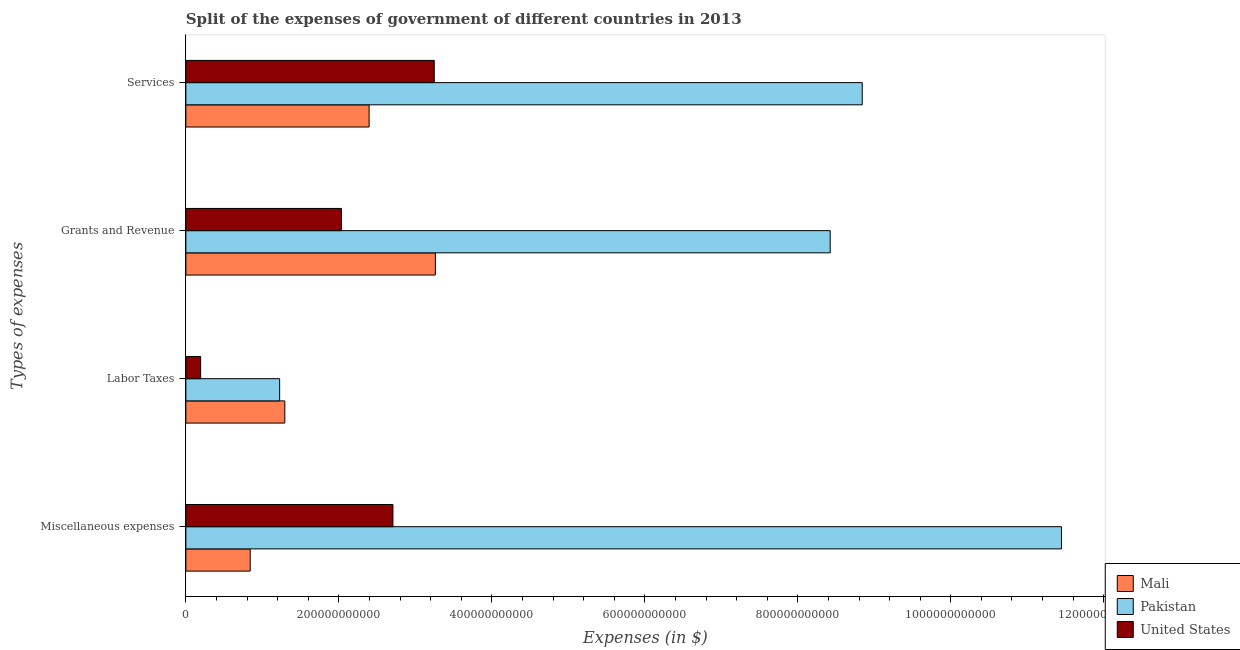How many different coloured bars are there?
Ensure brevity in your answer.  3. How many groups of bars are there?
Provide a succinct answer. 4. Are the number of bars per tick equal to the number of legend labels?
Your response must be concise. Yes. Are the number of bars on each tick of the Y-axis equal?
Give a very brief answer. Yes. How many bars are there on the 4th tick from the top?
Offer a terse response. 3. How many bars are there on the 3rd tick from the bottom?
Give a very brief answer. 3. What is the label of the 4th group of bars from the top?
Provide a succinct answer. Miscellaneous expenses. What is the amount spent on services in United States?
Keep it short and to the point. 3.25e+11. Across all countries, what is the maximum amount spent on grants and revenue?
Your answer should be compact. 8.42e+11. Across all countries, what is the minimum amount spent on labor taxes?
Ensure brevity in your answer.  1.93e+1. In which country was the amount spent on services minimum?
Your response must be concise. Mali. What is the total amount spent on labor taxes in the graph?
Keep it short and to the point. 2.71e+11. What is the difference between the amount spent on grants and revenue in United States and that in Mali?
Offer a terse response. -1.23e+11. What is the difference between the amount spent on labor taxes in Mali and the amount spent on miscellaneous expenses in United States?
Your response must be concise. -1.41e+11. What is the average amount spent on services per country?
Keep it short and to the point. 4.83e+11. What is the difference between the amount spent on miscellaneous expenses and amount spent on services in Pakistan?
Your response must be concise. 2.60e+11. In how many countries, is the amount spent on miscellaneous expenses greater than 160000000000 $?
Provide a short and direct response. 2. What is the ratio of the amount spent on services in United States to that in Mali?
Ensure brevity in your answer.  1.36. Is the amount spent on miscellaneous expenses in Pakistan less than that in United States?
Offer a very short reply. No. What is the difference between the highest and the second highest amount spent on services?
Offer a very short reply. 5.60e+11. What is the difference between the highest and the lowest amount spent on services?
Keep it short and to the point. 6.45e+11. Is it the case that in every country, the sum of the amount spent on labor taxes and amount spent on services is greater than the sum of amount spent on miscellaneous expenses and amount spent on grants and revenue?
Offer a terse response. No. What does the 3rd bar from the top in Miscellaneous expenses represents?
Keep it short and to the point. Mali. What does the 1st bar from the bottom in Labor Taxes represents?
Your answer should be compact. Mali. Is it the case that in every country, the sum of the amount spent on miscellaneous expenses and amount spent on labor taxes is greater than the amount spent on grants and revenue?
Your response must be concise. No. How many bars are there?
Your response must be concise. 12. How many countries are there in the graph?
Your answer should be compact. 3. What is the difference between two consecutive major ticks on the X-axis?
Your answer should be very brief. 2.00e+11. Does the graph contain any zero values?
Keep it short and to the point. No. Does the graph contain grids?
Give a very brief answer. No. How many legend labels are there?
Keep it short and to the point. 3. How are the legend labels stacked?
Offer a very short reply. Vertical. What is the title of the graph?
Keep it short and to the point. Split of the expenses of government of different countries in 2013. What is the label or title of the X-axis?
Give a very brief answer. Expenses (in $). What is the label or title of the Y-axis?
Your response must be concise. Types of expenses. What is the Expenses (in $) of Mali in Miscellaneous expenses?
Provide a short and direct response. 8.41e+1. What is the Expenses (in $) in Pakistan in Miscellaneous expenses?
Your response must be concise. 1.14e+12. What is the Expenses (in $) of United States in Miscellaneous expenses?
Provide a succinct answer. 2.71e+11. What is the Expenses (in $) of Mali in Labor Taxes?
Make the answer very short. 1.29e+11. What is the Expenses (in $) in Pakistan in Labor Taxes?
Offer a terse response. 1.23e+11. What is the Expenses (in $) in United States in Labor Taxes?
Provide a succinct answer. 1.93e+1. What is the Expenses (in $) in Mali in Grants and Revenue?
Offer a very short reply. 3.26e+11. What is the Expenses (in $) of Pakistan in Grants and Revenue?
Your answer should be compact. 8.42e+11. What is the Expenses (in $) in United States in Grants and Revenue?
Your response must be concise. 2.03e+11. What is the Expenses (in $) in Mali in Services?
Your answer should be very brief. 2.40e+11. What is the Expenses (in $) of Pakistan in Services?
Make the answer very short. 8.84e+11. What is the Expenses (in $) of United States in Services?
Keep it short and to the point. 3.25e+11. Across all Types of expenses, what is the maximum Expenses (in $) of Mali?
Give a very brief answer. 3.26e+11. Across all Types of expenses, what is the maximum Expenses (in $) of Pakistan?
Your answer should be very brief. 1.14e+12. Across all Types of expenses, what is the maximum Expenses (in $) in United States?
Your answer should be compact. 3.25e+11. Across all Types of expenses, what is the minimum Expenses (in $) of Mali?
Ensure brevity in your answer.  8.41e+1. Across all Types of expenses, what is the minimum Expenses (in $) of Pakistan?
Make the answer very short. 1.23e+11. Across all Types of expenses, what is the minimum Expenses (in $) of United States?
Provide a short and direct response. 1.93e+1. What is the total Expenses (in $) of Mali in the graph?
Give a very brief answer. 7.79e+11. What is the total Expenses (in $) in Pakistan in the graph?
Keep it short and to the point. 2.99e+12. What is the total Expenses (in $) in United States in the graph?
Offer a terse response. 8.18e+11. What is the difference between the Expenses (in $) in Mali in Miscellaneous expenses and that in Labor Taxes?
Make the answer very short. -4.52e+1. What is the difference between the Expenses (in $) in Pakistan in Miscellaneous expenses and that in Labor Taxes?
Offer a terse response. 1.02e+12. What is the difference between the Expenses (in $) in United States in Miscellaneous expenses and that in Labor Taxes?
Provide a short and direct response. 2.51e+11. What is the difference between the Expenses (in $) of Mali in Miscellaneous expenses and that in Grants and Revenue?
Make the answer very short. -2.42e+11. What is the difference between the Expenses (in $) in Pakistan in Miscellaneous expenses and that in Grants and Revenue?
Provide a succinct answer. 3.02e+11. What is the difference between the Expenses (in $) of United States in Miscellaneous expenses and that in Grants and Revenue?
Keep it short and to the point. 6.73e+1. What is the difference between the Expenses (in $) in Mali in Miscellaneous expenses and that in Services?
Your response must be concise. -1.55e+11. What is the difference between the Expenses (in $) of Pakistan in Miscellaneous expenses and that in Services?
Provide a succinct answer. 2.60e+11. What is the difference between the Expenses (in $) of United States in Miscellaneous expenses and that in Services?
Ensure brevity in your answer.  -5.40e+1. What is the difference between the Expenses (in $) in Mali in Labor Taxes and that in Grants and Revenue?
Your answer should be very brief. -1.97e+11. What is the difference between the Expenses (in $) in Pakistan in Labor Taxes and that in Grants and Revenue?
Offer a very short reply. -7.20e+11. What is the difference between the Expenses (in $) of United States in Labor Taxes and that in Grants and Revenue?
Offer a terse response. -1.84e+11. What is the difference between the Expenses (in $) of Mali in Labor Taxes and that in Services?
Your response must be concise. -1.10e+11. What is the difference between the Expenses (in $) in Pakistan in Labor Taxes and that in Services?
Make the answer very short. -7.62e+11. What is the difference between the Expenses (in $) in United States in Labor Taxes and that in Services?
Provide a succinct answer. -3.05e+11. What is the difference between the Expenses (in $) of Mali in Grants and Revenue and that in Services?
Your answer should be compact. 8.66e+1. What is the difference between the Expenses (in $) in Pakistan in Grants and Revenue and that in Services?
Make the answer very short. -4.19e+1. What is the difference between the Expenses (in $) of United States in Grants and Revenue and that in Services?
Keep it short and to the point. -1.21e+11. What is the difference between the Expenses (in $) in Mali in Miscellaneous expenses and the Expenses (in $) in Pakistan in Labor Taxes?
Give a very brief answer. -3.84e+1. What is the difference between the Expenses (in $) in Mali in Miscellaneous expenses and the Expenses (in $) in United States in Labor Taxes?
Offer a very short reply. 6.48e+1. What is the difference between the Expenses (in $) in Pakistan in Miscellaneous expenses and the Expenses (in $) in United States in Labor Taxes?
Ensure brevity in your answer.  1.13e+12. What is the difference between the Expenses (in $) of Mali in Miscellaneous expenses and the Expenses (in $) of Pakistan in Grants and Revenue?
Your answer should be very brief. -7.58e+11. What is the difference between the Expenses (in $) of Mali in Miscellaneous expenses and the Expenses (in $) of United States in Grants and Revenue?
Make the answer very short. -1.19e+11. What is the difference between the Expenses (in $) of Pakistan in Miscellaneous expenses and the Expenses (in $) of United States in Grants and Revenue?
Provide a succinct answer. 9.41e+11. What is the difference between the Expenses (in $) in Mali in Miscellaneous expenses and the Expenses (in $) in Pakistan in Services?
Give a very brief answer. -8.00e+11. What is the difference between the Expenses (in $) of Mali in Miscellaneous expenses and the Expenses (in $) of United States in Services?
Keep it short and to the point. -2.41e+11. What is the difference between the Expenses (in $) of Pakistan in Miscellaneous expenses and the Expenses (in $) of United States in Services?
Offer a terse response. 8.20e+11. What is the difference between the Expenses (in $) in Mali in Labor Taxes and the Expenses (in $) in Pakistan in Grants and Revenue?
Make the answer very short. -7.13e+11. What is the difference between the Expenses (in $) in Mali in Labor Taxes and the Expenses (in $) in United States in Grants and Revenue?
Offer a terse response. -7.41e+1. What is the difference between the Expenses (in $) in Pakistan in Labor Taxes and the Expenses (in $) in United States in Grants and Revenue?
Offer a terse response. -8.08e+1. What is the difference between the Expenses (in $) of Mali in Labor Taxes and the Expenses (in $) of Pakistan in Services?
Your answer should be compact. -7.55e+11. What is the difference between the Expenses (in $) of Mali in Labor Taxes and the Expenses (in $) of United States in Services?
Keep it short and to the point. -1.95e+11. What is the difference between the Expenses (in $) of Pakistan in Labor Taxes and the Expenses (in $) of United States in Services?
Make the answer very short. -2.02e+11. What is the difference between the Expenses (in $) in Mali in Grants and Revenue and the Expenses (in $) in Pakistan in Services?
Your answer should be compact. -5.58e+11. What is the difference between the Expenses (in $) in Mali in Grants and Revenue and the Expenses (in $) in United States in Services?
Your answer should be very brief. 1.47e+09. What is the difference between the Expenses (in $) of Pakistan in Grants and Revenue and the Expenses (in $) of United States in Services?
Ensure brevity in your answer.  5.18e+11. What is the average Expenses (in $) of Mali per Types of expenses?
Your answer should be very brief. 1.95e+11. What is the average Expenses (in $) of Pakistan per Types of expenses?
Provide a succinct answer. 7.48e+11. What is the average Expenses (in $) in United States per Types of expenses?
Offer a terse response. 2.05e+11. What is the difference between the Expenses (in $) in Mali and Expenses (in $) in Pakistan in Miscellaneous expenses?
Offer a very short reply. -1.06e+12. What is the difference between the Expenses (in $) of Mali and Expenses (in $) of United States in Miscellaneous expenses?
Offer a terse response. -1.87e+11. What is the difference between the Expenses (in $) of Pakistan and Expenses (in $) of United States in Miscellaneous expenses?
Keep it short and to the point. 8.74e+11. What is the difference between the Expenses (in $) in Mali and Expenses (in $) in Pakistan in Labor Taxes?
Offer a terse response. 6.76e+09. What is the difference between the Expenses (in $) in Mali and Expenses (in $) in United States in Labor Taxes?
Provide a succinct answer. 1.10e+11. What is the difference between the Expenses (in $) of Pakistan and Expenses (in $) of United States in Labor Taxes?
Provide a succinct answer. 1.03e+11. What is the difference between the Expenses (in $) in Mali and Expenses (in $) in Pakistan in Grants and Revenue?
Give a very brief answer. -5.16e+11. What is the difference between the Expenses (in $) in Mali and Expenses (in $) in United States in Grants and Revenue?
Ensure brevity in your answer.  1.23e+11. What is the difference between the Expenses (in $) of Pakistan and Expenses (in $) of United States in Grants and Revenue?
Your response must be concise. 6.39e+11. What is the difference between the Expenses (in $) in Mali and Expenses (in $) in Pakistan in Services?
Your response must be concise. -6.45e+11. What is the difference between the Expenses (in $) of Mali and Expenses (in $) of United States in Services?
Your response must be concise. -8.52e+1. What is the difference between the Expenses (in $) in Pakistan and Expenses (in $) in United States in Services?
Provide a succinct answer. 5.60e+11. What is the ratio of the Expenses (in $) in Mali in Miscellaneous expenses to that in Labor Taxes?
Provide a succinct answer. 0.65. What is the ratio of the Expenses (in $) in Pakistan in Miscellaneous expenses to that in Labor Taxes?
Keep it short and to the point. 9.34. What is the ratio of the Expenses (in $) of United States in Miscellaneous expenses to that in Labor Taxes?
Keep it short and to the point. 14.03. What is the ratio of the Expenses (in $) of Mali in Miscellaneous expenses to that in Grants and Revenue?
Provide a succinct answer. 0.26. What is the ratio of the Expenses (in $) in Pakistan in Miscellaneous expenses to that in Grants and Revenue?
Offer a very short reply. 1.36. What is the ratio of the Expenses (in $) of United States in Miscellaneous expenses to that in Grants and Revenue?
Ensure brevity in your answer.  1.33. What is the ratio of the Expenses (in $) of Mali in Miscellaneous expenses to that in Services?
Provide a succinct answer. 0.35. What is the ratio of the Expenses (in $) in Pakistan in Miscellaneous expenses to that in Services?
Provide a succinct answer. 1.29. What is the ratio of the Expenses (in $) of United States in Miscellaneous expenses to that in Services?
Keep it short and to the point. 0.83. What is the ratio of the Expenses (in $) in Mali in Labor Taxes to that in Grants and Revenue?
Your response must be concise. 0.4. What is the ratio of the Expenses (in $) in Pakistan in Labor Taxes to that in Grants and Revenue?
Ensure brevity in your answer.  0.15. What is the ratio of the Expenses (in $) in United States in Labor Taxes to that in Grants and Revenue?
Your answer should be very brief. 0.09. What is the ratio of the Expenses (in $) of Mali in Labor Taxes to that in Services?
Provide a short and direct response. 0.54. What is the ratio of the Expenses (in $) of Pakistan in Labor Taxes to that in Services?
Keep it short and to the point. 0.14. What is the ratio of the Expenses (in $) in United States in Labor Taxes to that in Services?
Your answer should be compact. 0.06. What is the ratio of the Expenses (in $) in Mali in Grants and Revenue to that in Services?
Your answer should be compact. 1.36. What is the ratio of the Expenses (in $) in Pakistan in Grants and Revenue to that in Services?
Give a very brief answer. 0.95. What is the ratio of the Expenses (in $) in United States in Grants and Revenue to that in Services?
Make the answer very short. 0.63. What is the difference between the highest and the second highest Expenses (in $) of Mali?
Offer a terse response. 8.66e+1. What is the difference between the highest and the second highest Expenses (in $) in Pakistan?
Provide a succinct answer. 2.60e+11. What is the difference between the highest and the second highest Expenses (in $) in United States?
Your answer should be very brief. 5.40e+1. What is the difference between the highest and the lowest Expenses (in $) in Mali?
Provide a short and direct response. 2.42e+11. What is the difference between the highest and the lowest Expenses (in $) of Pakistan?
Provide a short and direct response. 1.02e+12. What is the difference between the highest and the lowest Expenses (in $) of United States?
Offer a terse response. 3.05e+11. 